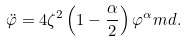Convert formula to latex. <formula><loc_0><loc_0><loc_500><loc_500>\ddot { \varphi } = 4 \zeta ^ { 2 } \left ( 1 - \frac { \alpha } { 2 } \right ) \varphi ^ { \alpha } \L m d .</formula> 